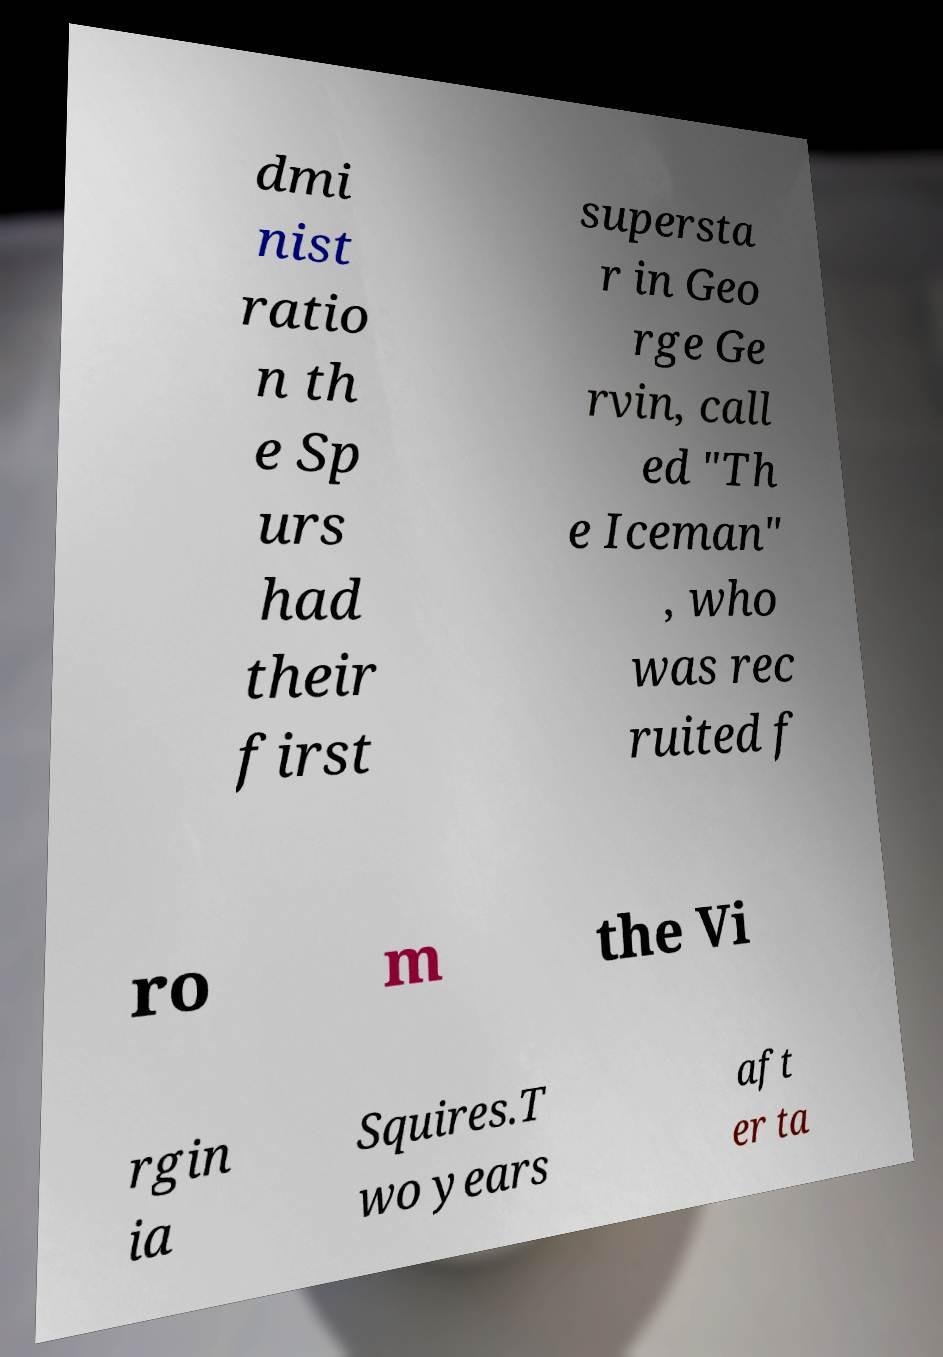There's text embedded in this image that I need extracted. Can you transcribe it verbatim? dmi nist ratio n th e Sp urs had their first supersta r in Geo rge Ge rvin, call ed "Th e Iceman" , who was rec ruited f ro m the Vi rgin ia Squires.T wo years aft er ta 